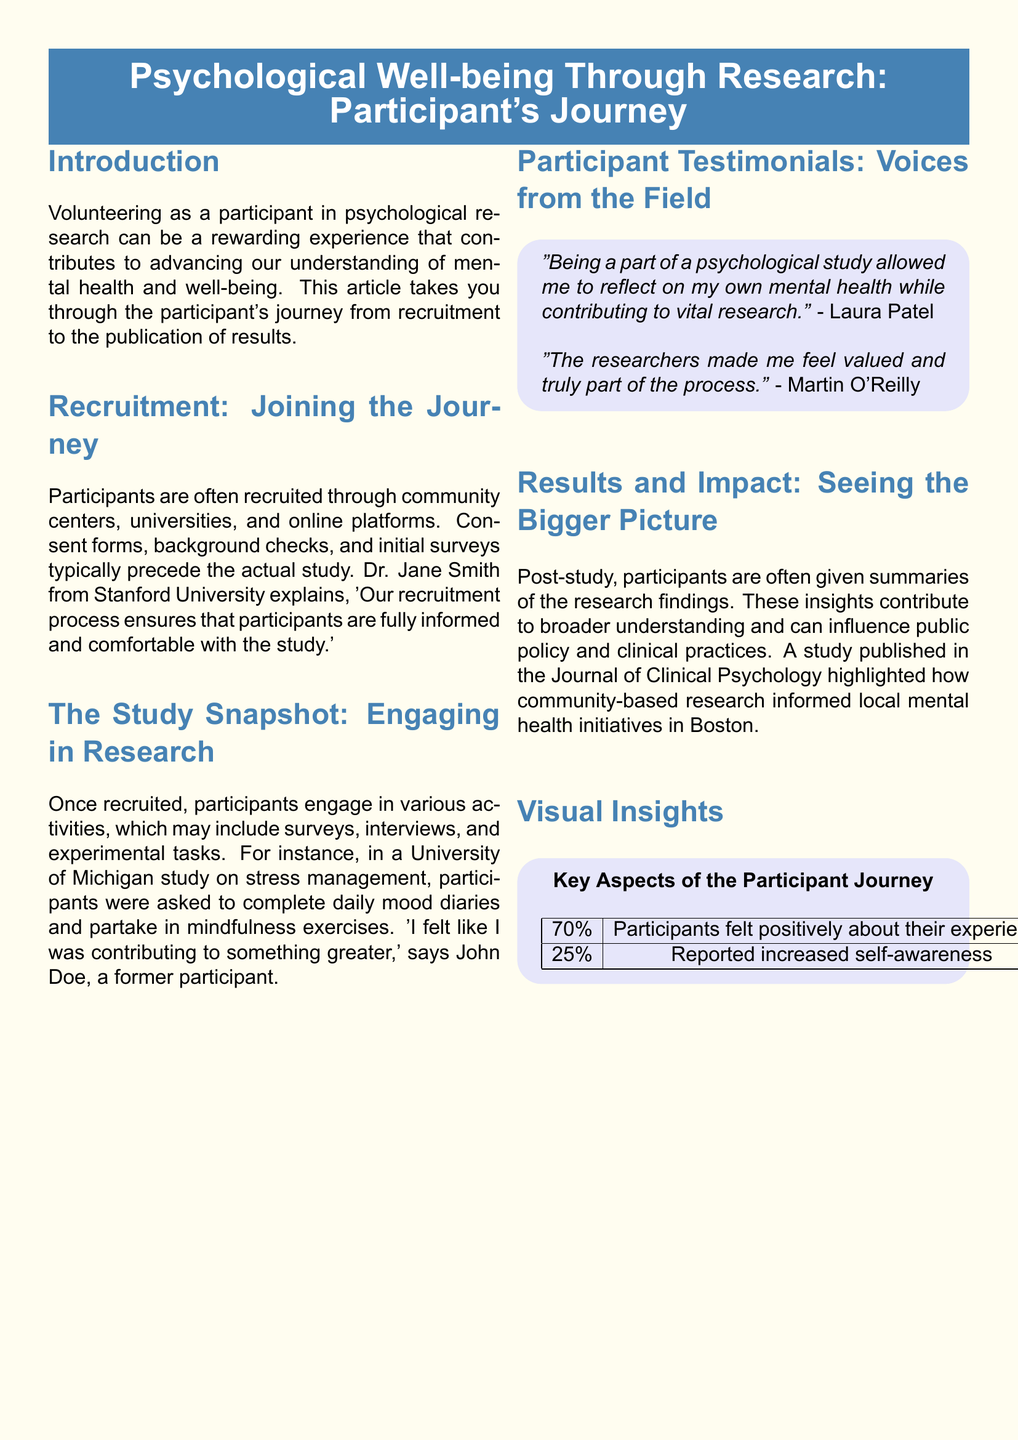what is the title of the article? The title is stated at the beginning of the document in a prominent box.
Answer: Psychological Well-being Through Research: Participant's Journey who is quoted in the recruitment section? The recruitment section includes a quote from Dr. Jane Smith regarding the recruitment process.
Answer: Dr. Jane Smith what percentage of participants felt positively about their experience? The visual insights section includes a statistic about participant experiences.
Answer: 70% what type of activities might participants engage in during a study? The study snapshot mentions several activities that participants may engage in.
Answer: surveys, interviews, experimental tasks who expressed a positive reflection on their mental health from participating? A participant testimonial highlights personal reflection alongside research contribution.
Answer: Laura Patel which journal published a study mentioned in the results section? The results section references a publication where community-based research findings were shared.
Answer: Journal of Clinical Psychology what did 25% of participants report after the study? The visual insights section shows a percentage related to participant self-awareness.
Answer: increased self-awareness which location was involved in the mental health initiatives mentioned? The results section discusses the impact of research on local initiatives.
Answer: Boston how is the layout of the document structured? The document uses a specific layout style common in magazine articles, including columns and sections.
Answer: columns and sections 